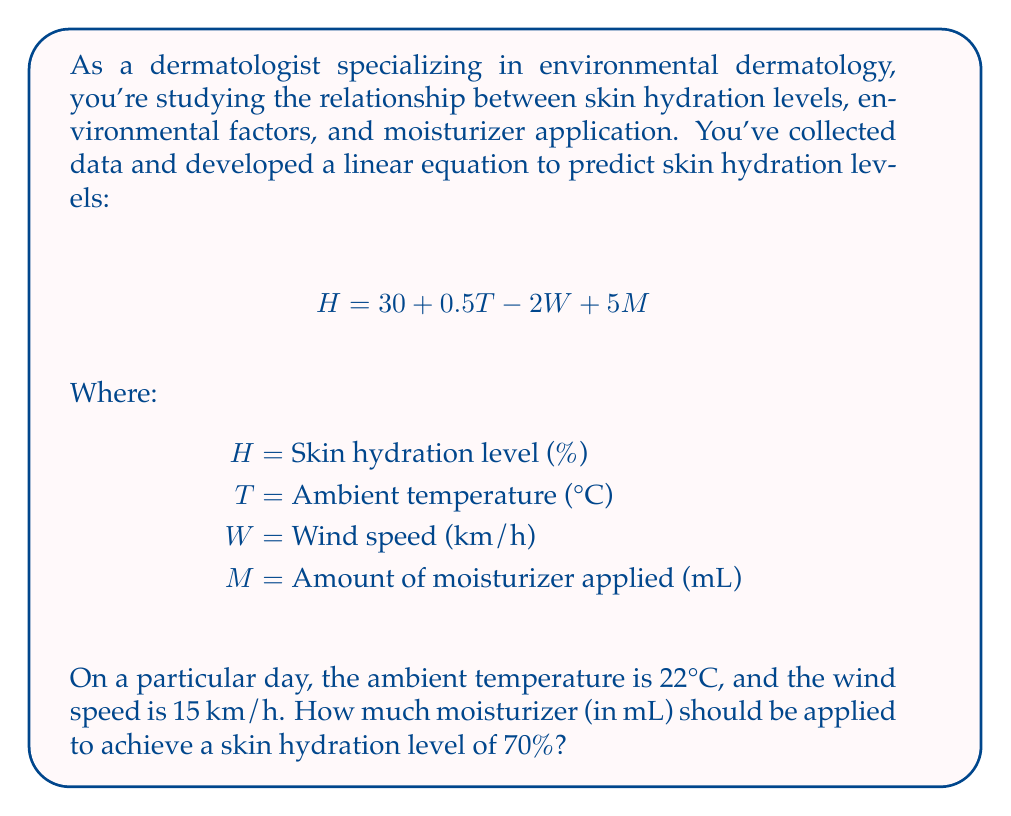What is the answer to this math problem? To solve this problem, we'll use the given linear equation and follow these steps:

1. Start with the equation:
   $$ H = 30 + 0.5T - 2W + 5M $$

2. Substitute the known values:
   $H = 70$ (desired hydration level)
   $T = 22$ (ambient temperature)
   $W = 15$ (wind speed)

3. Insert these values into the equation:
   $$ 70 = 30 + 0.5(22) - 2(15) + 5M $$

4. Simplify the equation:
   $$ 70 = 30 + 11 - 30 + 5M $$
   $$ 70 = 11 + 5M $$

5. Subtract 11 from both sides:
   $$ 59 = 5M $$

6. Divide both sides by 5 to isolate M:
   $$ \frac{59}{5} = M $$

7. Calculate the final result:
   $$ M = 11.8 $$

Therefore, 11.8 mL of moisturizer should be applied to achieve a skin hydration level of 70% under the given environmental conditions.
Answer: 11.8 mL of moisturizer 